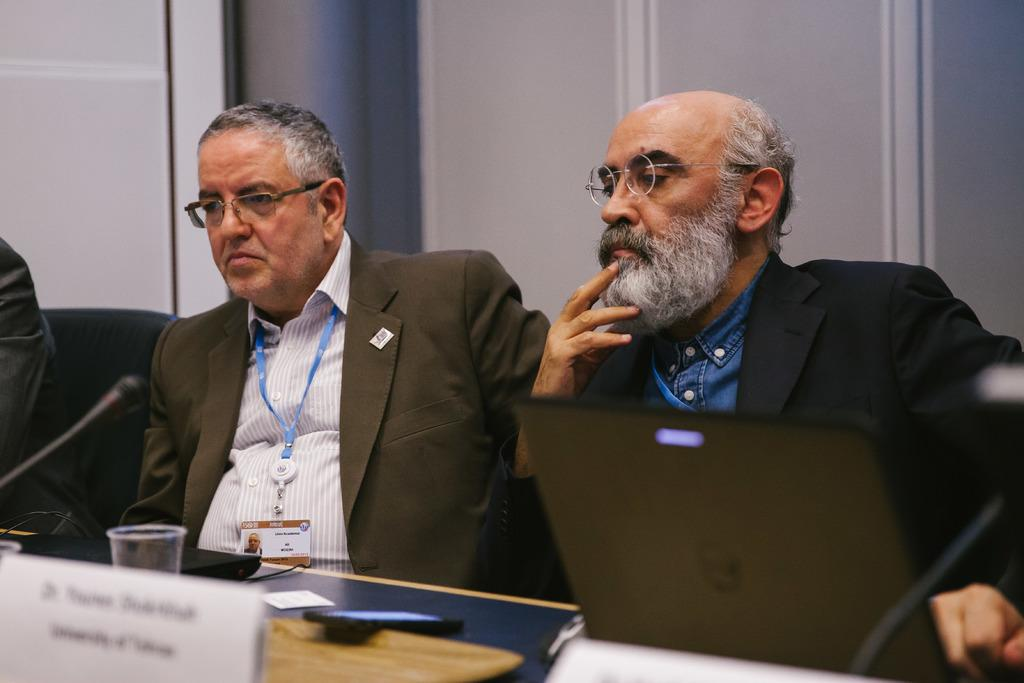How many people are sitting in the image? There are three persons sitting on chairs in the image. What objects can be seen on the table? There are glasses, name papers, microphones, laptops, and mobile phones on the table. What is visible in the background of the image? There is a wall in the background. Can you see a giraffe on the island in the image? There is no island or giraffe present in the image. What type of watch is the person wearing in the image? There is no watch visible on any of the persons in the image. 